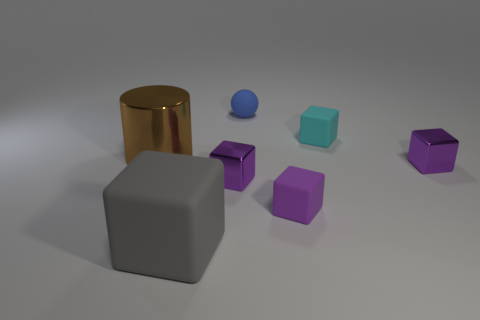Are there any other things that have the same shape as the big brown thing?
Keep it short and to the point. No. Does the thing behind the small cyan matte block have the same size as the gray thing left of the ball?
Provide a short and direct response. No. What is the shape of the big thing that is behind the large gray matte block to the left of the small cyan object?
Keep it short and to the point. Cylinder. How many matte cubes are on the right side of the tiny rubber ball?
Make the answer very short. 2. There is a large cube that is made of the same material as the ball; what is its color?
Ensure brevity in your answer.  Gray. Do the brown metallic cylinder and the purple metal block right of the matte ball have the same size?
Offer a terse response. No. There is a rubber cube behind the metal thing that is behind the tiny shiny thing that is on the right side of the small cyan matte cube; how big is it?
Make the answer very short. Small. What number of metallic things are small blue blocks or purple cubes?
Give a very brief answer. 2. There is a big thing that is behind the gray thing; what color is it?
Your response must be concise. Brown. The cyan thing that is the same size as the blue matte ball is what shape?
Offer a very short reply. Cube. 